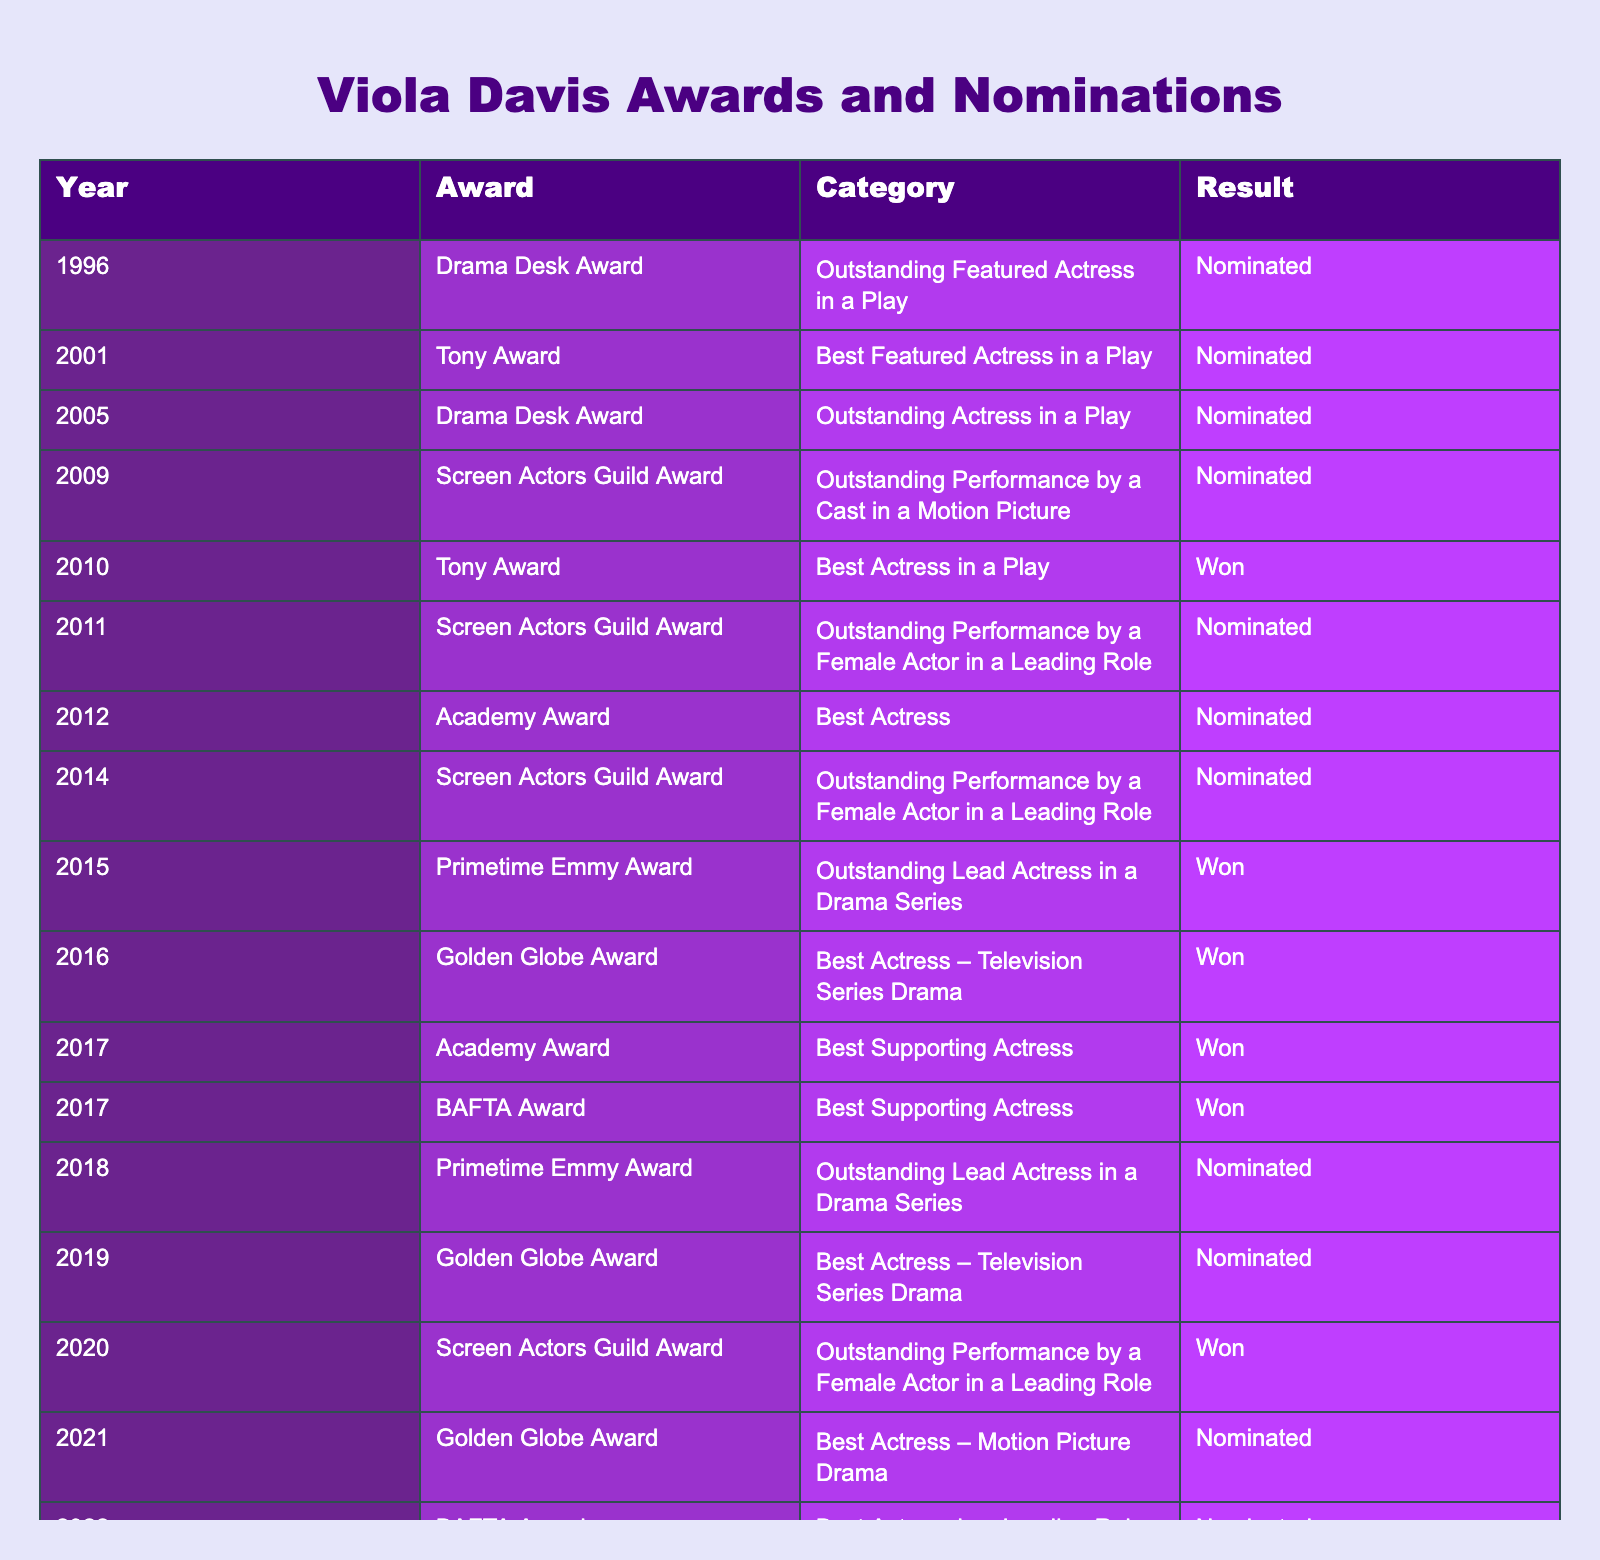What year did Viola Davis win her first Tony Award? The table shows that Viola Davis won her first Tony Award in 2010.
Answer: 2010 How many times has Viola Davis been nominated for an Academy Award? According to the table, Viola Davis has been nominated for the Academy Award twice: in 2012 and 2017.
Answer: 2 Which award did Viola Davis win in 2016? The table indicates that Viola Davis won the Golden Globe Award for Best Actress – Television Series Drama in 2016.
Answer: Golden Globe Award Was Viola Davis nominated for a Primetime Emmy Award in 2018? Yes, the table shows that she was nominated for a Primetime Emmy Award in 2018.
Answer: Yes What is the total number of awards Viola Davis won as listed in the table? The table outlines that Viola Davis won a total of four awards: one Tony Award, one Primetime Emmy Award, one Golden Globe Award, and two Academy Awards (since the 2017 Academy Award win is counted once). Therefore, the total is 1+1+1+2 = 4.
Answer: 4 In which years did Viola Davis receive nominations for the Screen Actors Guild Award? The table lists that she received nominations for the Screen Actors Guild Award in 2009, 2011, 2014, and 2020.
Answer: 2009, 2011, 2014, 2020 Among her nominations, how many resulted in wins? From the table, Viola Davis won 4 awards and was nominated 16 times, so 4/16 resulted in wins, meaning she had wins for 25% of her nominations.
Answer: 4 Which award did Viola Davis receive in the same year she won both a BAFTA and an Academy Award? The table shows that in 2017, Viola Davis won both the BAFTA Award and the Academy Award for Best Supporting Actress.
Answer: BAFTA Award, Academy Award How many nominations did Viola Davis receive in total for Golden Globe Awards? Viola Davis received a total of three nominations for Golden Globe Awards as listed in 2016, 2019, and 2021.
Answer: 3 What is the difference between the number of nominations and wins for Viola Davis in total? Viola Davis has a total of 16 nominations and 8 wins. The difference is 16 - 8 = 8.
Answer: 8 In which category did Viola Davis win her most recent award? The most recent win listed in the table for Viola Davis is in the category Best Actress – Motion Picture Drama at the Golden Globe Awards in 2023.
Answer: Best Actress – Motion Picture Drama 